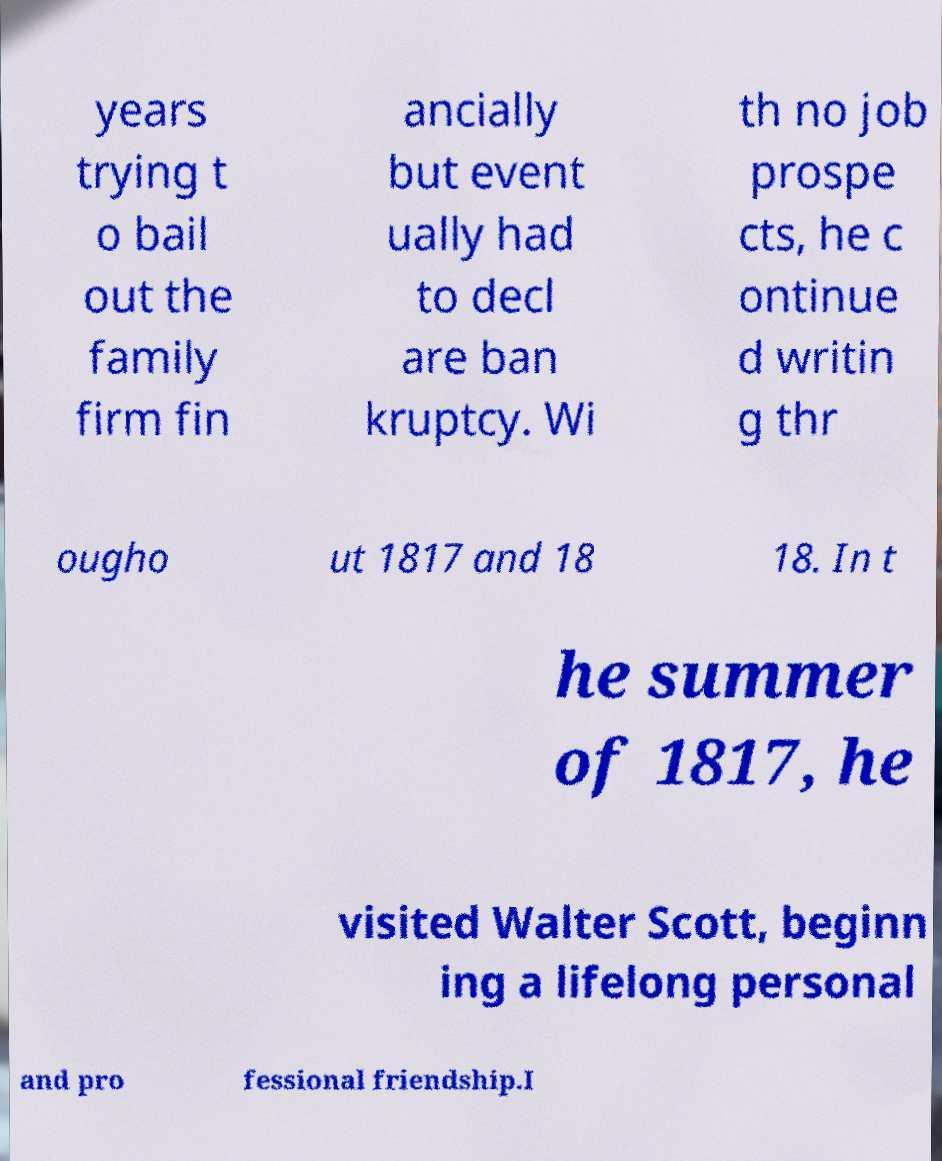Could you assist in decoding the text presented in this image and type it out clearly? years trying t o bail out the family firm fin ancially but event ually had to decl are ban kruptcy. Wi th no job prospe cts, he c ontinue d writin g thr ougho ut 1817 and 18 18. In t he summer of 1817, he visited Walter Scott, beginn ing a lifelong personal and pro fessional friendship.I 